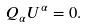Convert formula to latex. <formula><loc_0><loc_0><loc_500><loc_500>Q _ { \alpha } U ^ { \alpha } = 0 .</formula> 